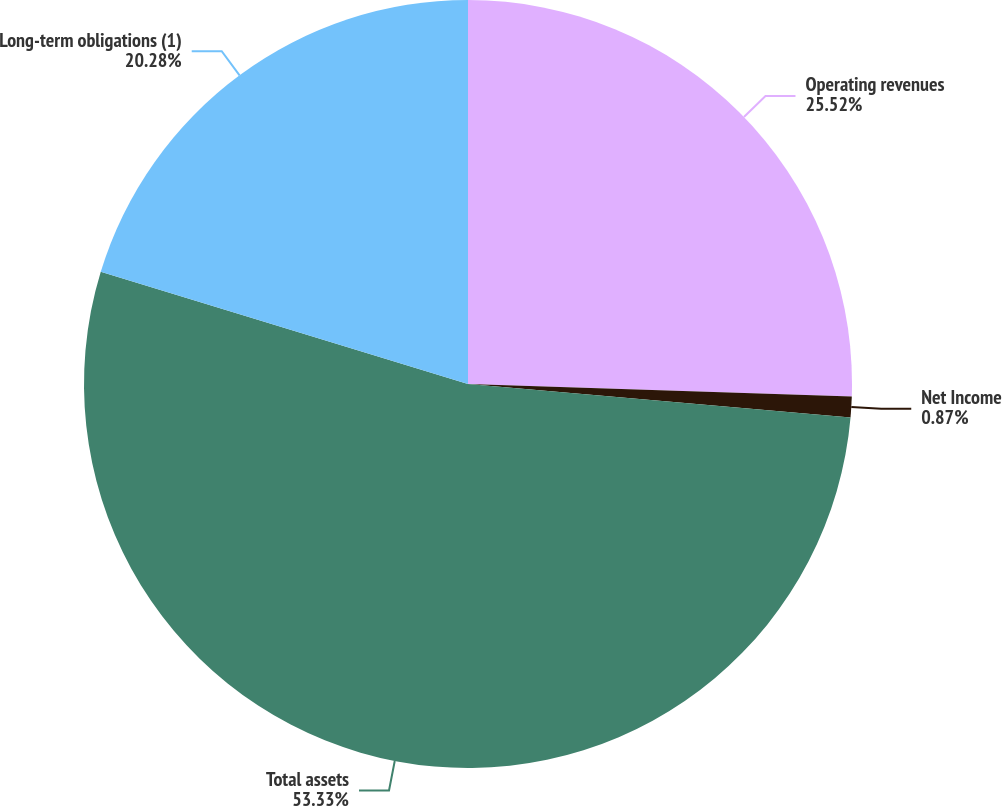Convert chart to OTSL. <chart><loc_0><loc_0><loc_500><loc_500><pie_chart><fcel>Operating revenues<fcel>Net Income<fcel>Total assets<fcel>Long-term obligations (1)<nl><fcel>25.52%<fcel>0.87%<fcel>53.33%<fcel>20.28%<nl></chart> 